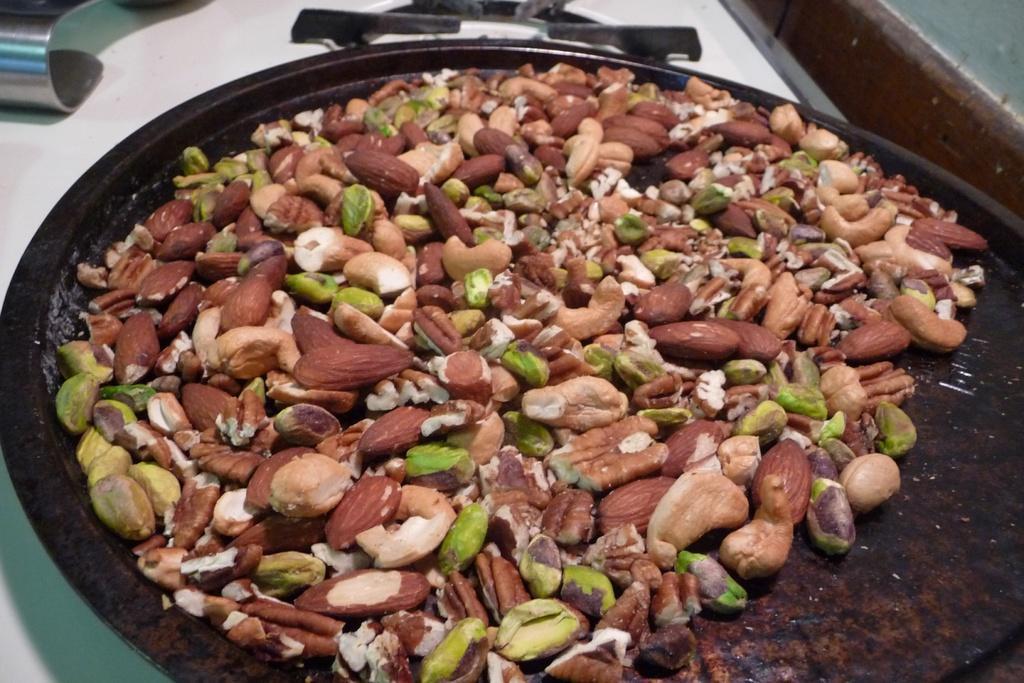Describe this image in one or two sentences. As we can see in the image there are different types of nuts and white color tiles. 